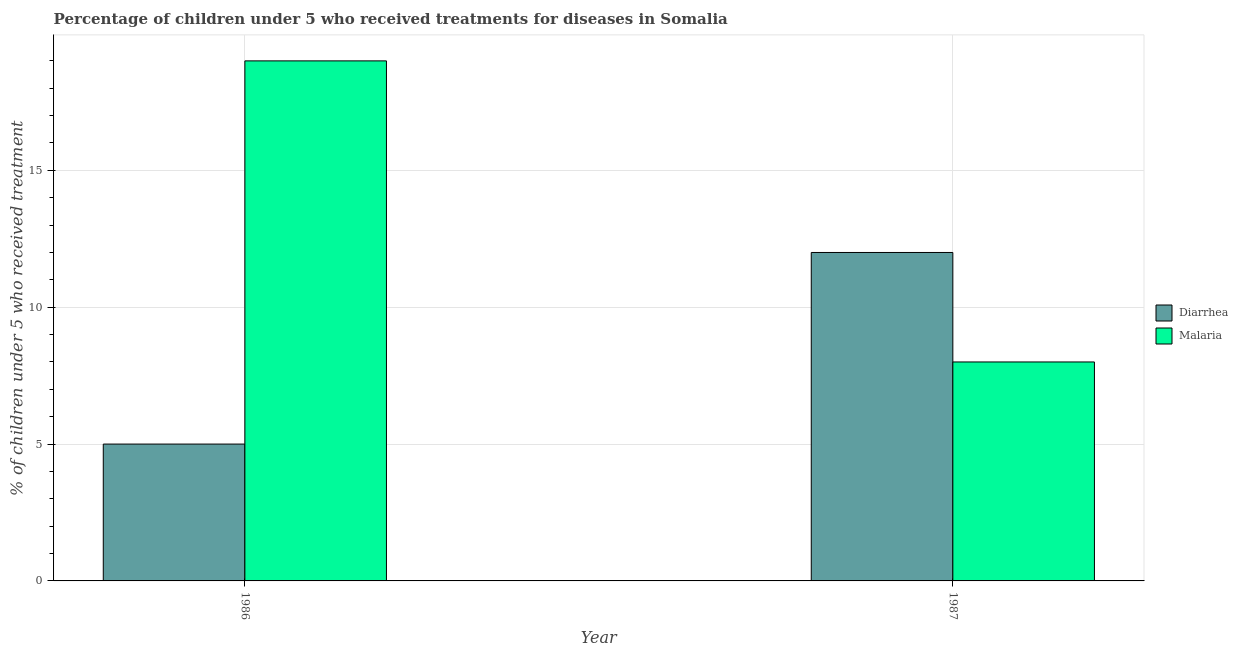How many different coloured bars are there?
Offer a terse response. 2. How many groups of bars are there?
Provide a short and direct response. 2. Are the number of bars per tick equal to the number of legend labels?
Offer a terse response. Yes. How many bars are there on the 1st tick from the right?
Give a very brief answer. 2. What is the label of the 1st group of bars from the left?
Your answer should be compact. 1986. In how many cases, is the number of bars for a given year not equal to the number of legend labels?
Ensure brevity in your answer.  0. What is the percentage of children who received treatment for diarrhoea in 1986?
Give a very brief answer. 5. Across all years, what is the maximum percentage of children who received treatment for diarrhoea?
Your answer should be compact. 12. Across all years, what is the minimum percentage of children who received treatment for malaria?
Your response must be concise. 8. In which year was the percentage of children who received treatment for malaria maximum?
Make the answer very short. 1986. What is the total percentage of children who received treatment for malaria in the graph?
Ensure brevity in your answer.  27. What is the difference between the percentage of children who received treatment for malaria in 1986 and that in 1987?
Offer a very short reply. 11. What is the difference between the percentage of children who received treatment for malaria in 1986 and the percentage of children who received treatment for diarrhoea in 1987?
Keep it short and to the point. 11. In the year 1986, what is the difference between the percentage of children who received treatment for diarrhoea and percentage of children who received treatment for malaria?
Offer a very short reply. 0. In how many years, is the percentage of children who received treatment for diarrhoea greater than 2 %?
Offer a terse response. 2. What is the ratio of the percentage of children who received treatment for diarrhoea in 1986 to that in 1987?
Offer a terse response. 0.42. Is the percentage of children who received treatment for diarrhoea in 1986 less than that in 1987?
Give a very brief answer. Yes. What does the 2nd bar from the left in 1987 represents?
Provide a short and direct response. Malaria. What does the 2nd bar from the right in 1986 represents?
Offer a terse response. Diarrhea. Are all the bars in the graph horizontal?
Keep it short and to the point. No. Are the values on the major ticks of Y-axis written in scientific E-notation?
Ensure brevity in your answer.  No. Where does the legend appear in the graph?
Ensure brevity in your answer.  Center right. What is the title of the graph?
Ensure brevity in your answer.  Percentage of children under 5 who received treatments for diseases in Somalia. What is the label or title of the X-axis?
Your response must be concise. Year. What is the label or title of the Y-axis?
Make the answer very short. % of children under 5 who received treatment. What is the % of children under 5 who received treatment in Diarrhea in 1986?
Offer a very short reply. 5. What is the % of children under 5 who received treatment in Malaria in 1986?
Offer a terse response. 19. What is the % of children under 5 who received treatment of Malaria in 1987?
Ensure brevity in your answer.  8. Across all years, what is the maximum % of children under 5 who received treatment in Malaria?
Offer a very short reply. 19. Across all years, what is the minimum % of children under 5 who received treatment in Diarrhea?
Offer a very short reply. 5. Across all years, what is the minimum % of children under 5 who received treatment of Malaria?
Keep it short and to the point. 8. What is the total % of children under 5 who received treatment of Diarrhea in the graph?
Give a very brief answer. 17. What is the difference between the % of children under 5 who received treatment of Diarrhea in 1986 and that in 1987?
Your response must be concise. -7. What is the average % of children under 5 who received treatment in Malaria per year?
Make the answer very short. 13.5. In the year 1987, what is the difference between the % of children under 5 who received treatment of Diarrhea and % of children under 5 who received treatment of Malaria?
Keep it short and to the point. 4. What is the ratio of the % of children under 5 who received treatment in Diarrhea in 1986 to that in 1987?
Keep it short and to the point. 0.42. What is the ratio of the % of children under 5 who received treatment of Malaria in 1986 to that in 1987?
Provide a succinct answer. 2.38. What is the difference between the highest and the second highest % of children under 5 who received treatment of Malaria?
Your answer should be very brief. 11. What is the difference between the highest and the lowest % of children under 5 who received treatment in Diarrhea?
Provide a short and direct response. 7. What is the difference between the highest and the lowest % of children under 5 who received treatment in Malaria?
Offer a terse response. 11. 